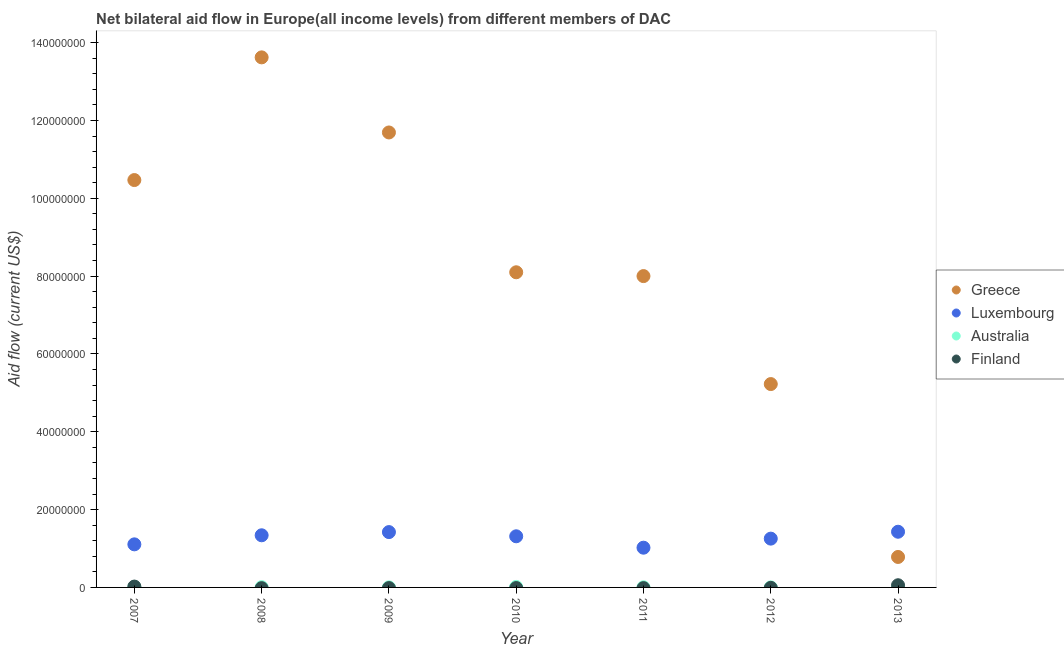How many different coloured dotlines are there?
Your answer should be compact. 4. What is the amount of aid given by australia in 2007?
Keep it short and to the point. 1.20e+05. Across all years, what is the maximum amount of aid given by luxembourg?
Give a very brief answer. 1.43e+07. Across all years, what is the minimum amount of aid given by greece?
Provide a short and direct response. 7.83e+06. What is the total amount of aid given by luxembourg in the graph?
Offer a terse response. 8.89e+07. What is the difference between the amount of aid given by greece in 2007 and that in 2010?
Give a very brief answer. 2.37e+07. What is the difference between the amount of aid given by greece in 2013 and the amount of aid given by australia in 2008?
Offer a terse response. 7.76e+06. What is the average amount of aid given by australia per year?
Your answer should be very brief. 5.86e+04. In the year 2009, what is the difference between the amount of aid given by luxembourg and amount of aid given by australia?
Offer a very short reply. 1.42e+07. What is the ratio of the amount of aid given by greece in 2008 to that in 2013?
Offer a terse response. 17.4. Is the amount of aid given by greece in 2009 less than that in 2011?
Make the answer very short. No. Is the difference between the amount of aid given by greece in 2008 and 2009 greater than the difference between the amount of aid given by australia in 2008 and 2009?
Provide a short and direct response. Yes. What is the difference between the highest and the second highest amount of aid given by luxembourg?
Ensure brevity in your answer.  9.00e+04. What is the difference between the highest and the lowest amount of aid given by finland?
Offer a very short reply. 5.60e+05. In how many years, is the amount of aid given by finland greater than the average amount of aid given by finland taken over all years?
Your response must be concise. 2. Is the sum of the amount of aid given by greece in 2012 and 2013 greater than the maximum amount of aid given by finland across all years?
Provide a short and direct response. Yes. Is it the case that in every year, the sum of the amount of aid given by luxembourg and amount of aid given by australia is greater than the sum of amount of aid given by greece and amount of aid given by finland?
Your answer should be compact. Yes. Is it the case that in every year, the sum of the amount of aid given by greece and amount of aid given by luxembourg is greater than the amount of aid given by australia?
Provide a short and direct response. Yes. Are the values on the major ticks of Y-axis written in scientific E-notation?
Make the answer very short. No. Does the graph contain any zero values?
Offer a very short reply. Yes. How are the legend labels stacked?
Your response must be concise. Vertical. What is the title of the graph?
Offer a terse response. Net bilateral aid flow in Europe(all income levels) from different members of DAC. Does "Methodology assessment" appear as one of the legend labels in the graph?
Give a very brief answer. No. What is the label or title of the Y-axis?
Make the answer very short. Aid flow (current US$). What is the Aid flow (current US$) of Greece in 2007?
Your answer should be very brief. 1.05e+08. What is the Aid flow (current US$) of Luxembourg in 2007?
Your answer should be compact. 1.11e+07. What is the Aid flow (current US$) in Finland in 2007?
Provide a short and direct response. 2.20e+05. What is the Aid flow (current US$) of Greece in 2008?
Provide a succinct answer. 1.36e+08. What is the Aid flow (current US$) of Luxembourg in 2008?
Make the answer very short. 1.34e+07. What is the Aid flow (current US$) of Finland in 2008?
Give a very brief answer. 0. What is the Aid flow (current US$) of Greece in 2009?
Keep it short and to the point. 1.17e+08. What is the Aid flow (current US$) in Luxembourg in 2009?
Provide a succinct answer. 1.42e+07. What is the Aid flow (current US$) of Australia in 2009?
Make the answer very short. 2.00e+04. What is the Aid flow (current US$) in Greece in 2010?
Your answer should be compact. 8.10e+07. What is the Aid flow (current US$) of Luxembourg in 2010?
Provide a short and direct response. 1.31e+07. What is the Aid flow (current US$) of Greece in 2011?
Your answer should be very brief. 8.00e+07. What is the Aid flow (current US$) in Luxembourg in 2011?
Offer a very short reply. 1.02e+07. What is the Aid flow (current US$) of Greece in 2012?
Make the answer very short. 5.23e+07. What is the Aid flow (current US$) in Luxembourg in 2012?
Provide a succinct answer. 1.25e+07. What is the Aid flow (current US$) in Australia in 2012?
Provide a succinct answer. 10000. What is the Aid flow (current US$) in Greece in 2013?
Your answer should be very brief. 7.83e+06. What is the Aid flow (current US$) in Luxembourg in 2013?
Your response must be concise. 1.43e+07. What is the Aid flow (current US$) in Finland in 2013?
Keep it short and to the point. 5.60e+05. Across all years, what is the maximum Aid flow (current US$) of Greece?
Make the answer very short. 1.36e+08. Across all years, what is the maximum Aid flow (current US$) in Luxembourg?
Provide a succinct answer. 1.43e+07. Across all years, what is the maximum Aid flow (current US$) of Australia?
Provide a short and direct response. 1.30e+05. Across all years, what is the maximum Aid flow (current US$) of Finland?
Your answer should be compact. 5.60e+05. Across all years, what is the minimum Aid flow (current US$) in Greece?
Make the answer very short. 7.83e+06. Across all years, what is the minimum Aid flow (current US$) of Luxembourg?
Offer a very short reply. 1.02e+07. Across all years, what is the minimum Aid flow (current US$) in Australia?
Offer a terse response. 10000. Across all years, what is the minimum Aid flow (current US$) in Finland?
Make the answer very short. 0. What is the total Aid flow (current US$) in Greece in the graph?
Offer a very short reply. 5.79e+08. What is the total Aid flow (current US$) of Luxembourg in the graph?
Offer a terse response. 8.89e+07. What is the total Aid flow (current US$) in Australia in the graph?
Give a very brief answer. 4.10e+05. What is the total Aid flow (current US$) in Finland in the graph?
Offer a terse response. 7.80e+05. What is the difference between the Aid flow (current US$) of Greece in 2007 and that in 2008?
Ensure brevity in your answer.  -3.15e+07. What is the difference between the Aid flow (current US$) in Luxembourg in 2007 and that in 2008?
Your answer should be compact. -2.33e+06. What is the difference between the Aid flow (current US$) in Australia in 2007 and that in 2008?
Offer a very short reply. 5.00e+04. What is the difference between the Aid flow (current US$) of Greece in 2007 and that in 2009?
Your response must be concise. -1.22e+07. What is the difference between the Aid flow (current US$) in Luxembourg in 2007 and that in 2009?
Ensure brevity in your answer.  -3.15e+06. What is the difference between the Aid flow (current US$) of Australia in 2007 and that in 2009?
Provide a short and direct response. 1.00e+05. What is the difference between the Aid flow (current US$) in Greece in 2007 and that in 2010?
Provide a succinct answer. 2.37e+07. What is the difference between the Aid flow (current US$) in Luxembourg in 2007 and that in 2010?
Your answer should be compact. -2.07e+06. What is the difference between the Aid flow (current US$) of Greece in 2007 and that in 2011?
Ensure brevity in your answer.  2.47e+07. What is the difference between the Aid flow (current US$) of Luxembourg in 2007 and that in 2011?
Ensure brevity in your answer.  8.60e+05. What is the difference between the Aid flow (current US$) of Greece in 2007 and that in 2012?
Your answer should be compact. 5.24e+07. What is the difference between the Aid flow (current US$) in Luxembourg in 2007 and that in 2012?
Keep it short and to the point. -1.47e+06. What is the difference between the Aid flow (current US$) of Greece in 2007 and that in 2013?
Keep it short and to the point. 9.69e+07. What is the difference between the Aid flow (current US$) of Luxembourg in 2007 and that in 2013?
Provide a short and direct response. -3.24e+06. What is the difference between the Aid flow (current US$) in Australia in 2007 and that in 2013?
Make the answer very short. 1.00e+05. What is the difference between the Aid flow (current US$) in Greece in 2008 and that in 2009?
Offer a very short reply. 1.93e+07. What is the difference between the Aid flow (current US$) in Luxembourg in 2008 and that in 2009?
Keep it short and to the point. -8.20e+05. What is the difference between the Aid flow (current US$) in Australia in 2008 and that in 2009?
Give a very brief answer. 5.00e+04. What is the difference between the Aid flow (current US$) in Greece in 2008 and that in 2010?
Offer a very short reply. 5.52e+07. What is the difference between the Aid flow (current US$) of Luxembourg in 2008 and that in 2010?
Offer a very short reply. 2.60e+05. What is the difference between the Aid flow (current US$) in Greece in 2008 and that in 2011?
Your answer should be compact. 5.62e+07. What is the difference between the Aid flow (current US$) in Luxembourg in 2008 and that in 2011?
Offer a very short reply. 3.19e+06. What is the difference between the Aid flow (current US$) in Australia in 2008 and that in 2011?
Provide a short and direct response. 3.00e+04. What is the difference between the Aid flow (current US$) of Greece in 2008 and that in 2012?
Keep it short and to the point. 8.40e+07. What is the difference between the Aid flow (current US$) of Luxembourg in 2008 and that in 2012?
Offer a very short reply. 8.60e+05. What is the difference between the Aid flow (current US$) of Australia in 2008 and that in 2012?
Your response must be concise. 6.00e+04. What is the difference between the Aid flow (current US$) in Greece in 2008 and that in 2013?
Make the answer very short. 1.28e+08. What is the difference between the Aid flow (current US$) in Luxembourg in 2008 and that in 2013?
Provide a short and direct response. -9.10e+05. What is the difference between the Aid flow (current US$) of Australia in 2008 and that in 2013?
Provide a short and direct response. 5.00e+04. What is the difference between the Aid flow (current US$) in Greece in 2009 and that in 2010?
Provide a short and direct response. 3.59e+07. What is the difference between the Aid flow (current US$) of Luxembourg in 2009 and that in 2010?
Ensure brevity in your answer.  1.08e+06. What is the difference between the Aid flow (current US$) of Australia in 2009 and that in 2010?
Offer a very short reply. -1.10e+05. What is the difference between the Aid flow (current US$) of Greece in 2009 and that in 2011?
Provide a succinct answer. 3.69e+07. What is the difference between the Aid flow (current US$) of Luxembourg in 2009 and that in 2011?
Keep it short and to the point. 4.01e+06. What is the difference between the Aid flow (current US$) in Greece in 2009 and that in 2012?
Give a very brief answer. 6.47e+07. What is the difference between the Aid flow (current US$) in Luxembourg in 2009 and that in 2012?
Offer a terse response. 1.68e+06. What is the difference between the Aid flow (current US$) of Australia in 2009 and that in 2012?
Make the answer very short. 10000. What is the difference between the Aid flow (current US$) in Greece in 2009 and that in 2013?
Keep it short and to the point. 1.09e+08. What is the difference between the Aid flow (current US$) of Luxembourg in 2009 and that in 2013?
Ensure brevity in your answer.  -9.00e+04. What is the difference between the Aid flow (current US$) of Greece in 2010 and that in 2011?
Provide a short and direct response. 9.80e+05. What is the difference between the Aid flow (current US$) in Luxembourg in 2010 and that in 2011?
Provide a short and direct response. 2.93e+06. What is the difference between the Aid flow (current US$) in Australia in 2010 and that in 2011?
Provide a short and direct response. 9.00e+04. What is the difference between the Aid flow (current US$) of Greece in 2010 and that in 2012?
Provide a short and direct response. 2.87e+07. What is the difference between the Aid flow (current US$) in Luxembourg in 2010 and that in 2012?
Provide a short and direct response. 6.00e+05. What is the difference between the Aid flow (current US$) in Greece in 2010 and that in 2013?
Offer a very short reply. 7.32e+07. What is the difference between the Aid flow (current US$) of Luxembourg in 2010 and that in 2013?
Make the answer very short. -1.17e+06. What is the difference between the Aid flow (current US$) of Greece in 2011 and that in 2012?
Give a very brief answer. 2.78e+07. What is the difference between the Aid flow (current US$) in Luxembourg in 2011 and that in 2012?
Provide a succinct answer. -2.33e+06. What is the difference between the Aid flow (current US$) in Greece in 2011 and that in 2013?
Offer a very short reply. 7.22e+07. What is the difference between the Aid flow (current US$) in Luxembourg in 2011 and that in 2013?
Provide a succinct answer. -4.10e+06. What is the difference between the Aid flow (current US$) of Australia in 2011 and that in 2013?
Your answer should be very brief. 2.00e+04. What is the difference between the Aid flow (current US$) of Greece in 2012 and that in 2013?
Keep it short and to the point. 4.44e+07. What is the difference between the Aid flow (current US$) of Luxembourg in 2012 and that in 2013?
Ensure brevity in your answer.  -1.77e+06. What is the difference between the Aid flow (current US$) of Greece in 2007 and the Aid flow (current US$) of Luxembourg in 2008?
Ensure brevity in your answer.  9.13e+07. What is the difference between the Aid flow (current US$) in Greece in 2007 and the Aid flow (current US$) in Australia in 2008?
Offer a very short reply. 1.05e+08. What is the difference between the Aid flow (current US$) in Luxembourg in 2007 and the Aid flow (current US$) in Australia in 2008?
Provide a succinct answer. 1.10e+07. What is the difference between the Aid flow (current US$) of Greece in 2007 and the Aid flow (current US$) of Luxembourg in 2009?
Your answer should be compact. 9.05e+07. What is the difference between the Aid flow (current US$) in Greece in 2007 and the Aid flow (current US$) in Australia in 2009?
Keep it short and to the point. 1.05e+08. What is the difference between the Aid flow (current US$) in Luxembourg in 2007 and the Aid flow (current US$) in Australia in 2009?
Offer a terse response. 1.10e+07. What is the difference between the Aid flow (current US$) of Greece in 2007 and the Aid flow (current US$) of Luxembourg in 2010?
Your answer should be very brief. 9.16e+07. What is the difference between the Aid flow (current US$) of Greece in 2007 and the Aid flow (current US$) of Australia in 2010?
Offer a very short reply. 1.05e+08. What is the difference between the Aid flow (current US$) in Luxembourg in 2007 and the Aid flow (current US$) in Australia in 2010?
Give a very brief answer. 1.09e+07. What is the difference between the Aid flow (current US$) in Greece in 2007 and the Aid flow (current US$) in Luxembourg in 2011?
Give a very brief answer. 9.45e+07. What is the difference between the Aid flow (current US$) of Greece in 2007 and the Aid flow (current US$) of Australia in 2011?
Keep it short and to the point. 1.05e+08. What is the difference between the Aid flow (current US$) of Luxembourg in 2007 and the Aid flow (current US$) of Australia in 2011?
Give a very brief answer. 1.10e+07. What is the difference between the Aid flow (current US$) in Greece in 2007 and the Aid flow (current US$) in Luxembourg in 2012?
Your answer should be very brief. 9.22e+07. What is the difference between the Aid flow (current US$) of Greece in 2007 and the Aid flow (current US$) of Australia in 2012?
Provide a short and direct response. 1.05e+08. What is the difference between the Aid flow (current US$) of Luxembourg in 2007 and the Aid flow (current US$) of Australia in 2012?
Make the answer very short. 1.11e+07. What is the difference between the Aid flow (current US$) of Greece in 2007 and the Aid flow (current US$) of Luxembourg in 2013?
Your answer should be compact. 9.04e+07. What is the difference between the Aid flow (current US$) of Greece in 2007 and the Aid flow (current US$) of Australia in 2013?
Your response must be concise. 1.05e+08. What is the difference between the Aid flow (current US$) in Greece in 2007 and the Aid flow (current US$) in Finland in 2013?
Give a very brief answer. 1.04e+08. What is the difference between the Aid flow (current US$) of Luxembourg in 2007 and the Aid flow (current US$) of Australia in 2013?
Offer a terse response. 1.10e+07. What is the difference between the Aid flow (current US$) of Luxembourg in 2007 and the Aid flow (current US$) of Finland in 2013?
Give a very brief answer. 1.05e+07. What is the difference between the Aid flow (current US$) in Australia in 2007 and the Aid flow (current US$) in Finland in 2013?
Your response must be concise. -4.40e+05. What is the difference between the Aid flow (current US$) of Greece in 2008 and the Aid flow (current US$) of Luxembourg in 2009?
Provide a succinct answer. 1.22e+08. What is the difference between the Aid flow (current US$) in Greece in 2008 and the Aid flow (current US$) in Australia in 2009?
Your answer should be compact. 1.36e+08. What is the difference between the Aid flow (current US$) in Luxembourg in 2008 and the Aid flow (current US$) in Australia in 2009?
Keep it short and to the point. 1.34e+07. What is the difference between the Aid flow (current US$) of Greece in 2008 and the Aid flow (current US$) of Luxembourg in 2010?
Keep it short and to the point. 1.23e+08. What is the difference between the Aid flow (current US$) of Greece in 2008 and the Aid flow (current US$) of Australia in 2010?
Provide a short and direct response. 1.36e+08. What is the difference between the Aid flow (current US$) of Luxembourg in 2008 and the Aid flow (current US$) of Australia in 2010?
Provide a succinct answer. 1.33e+07. What is the difference between the Aid flow (current US$) of Greece in 2008 and the Aid flow (current US$) of Luxembourg in 2011?
Keep it short and to the point. 1.26e+08. What is the difference between the Aid flow (current US$) in Greece in 2008 and the Aid flow (current US$) in Australia in 2011?
Offer a terse response. 1.36e+08. What is the difference between the Aid flow (current US$) of Luxembourg in 2008 and the Aid flow (current US$) of Australia in 2011?
Provide a succinct answer. 1.34e+07. What is the difference between the Aid flow (current US$) of Greece in 2008 and the Aid flow (current US$) of Luxembourg in 2012?
Keep it short and to the point. 1.24e+08. What is the difference between the Aid flow (current US$) in Greece in 2008 and the Aid flow (current US$) in Australia in 2012?
Keep it short and to the point. 1.36e+08. What is the difference between the Aid flow (current US$) in Luxembourg in 2008 and the Aid flow (current US$) in Australia in 2012?
Your response must be concise. 1.34e+07. What is the difference between the Aid flow (current US$) in Greece in 2008 and the Aid flow (current US$) in Luxembourg in 2013?
Your answer should be very brief. 1.22e+08. What is the difference between the Aid flow (current US$) in Greece in 2008 and the Aid flow (current US$) in Australia in 2013?
Your answer should be very brief. 1.36e+08. What is the difference between the Aid flow (current US$) of Greece in 2008 and the Aid flow (current US$) of Finland in 2013?
Provide a short and direct response. 1.36e+08. What is the difference between the Aid flow (current US$) of Luxembourg in 2008 and the Aid flow (current US$) of Australia in 2013?
Offer a very short reply. 1.34e+07. What is the difference between the Aid flow (current US$) of Luxembourg in 2008 and the Aid flow (current US$) of Finland in 2013?
Give a very brief answer. 1.28e+07. What is the difference between the Aid flow (current US$) in Australia in 2008 and the Aid flow (current US$) in Finland in 2013?
Keep it short and to the point. -4.90e+05. What is the difference between the Aid flow (current US$) in Greece in 2009 and the Aid flow (current US$) in Luxembourg in 2010?
Your answer should be very brief. 1.04e+08. What is the difference between the Aid flow (current US$) in Greece in 2009 and the Aid flow (current US$) in Australia in 2010?
Your answer should be compact. 1.17e+08. What is the difference between the Aid flow (current US$) in Luxembourg in 2009 and the Aid flow (current US$) in Australia in 2010?
Provide a succinct answer. 1.41e+07. What is the difference between the Aid flow (current US$) of Greece in 2009 and the Aid flow (current US$) of Luxembourg in 2011?
Keep it short and to the point. 1.07e+08. What is the difference between the Aid flow (current US$) in Greece in 2009 and the Aid flow (current US$) in Australia in 2011?
Offer a very short reply. 1.17e+08. What is the difference between the Aid flow (current US$) of Luxembourg in 2009 and the Aid flow (current US$) of Australia in 2011?
Give a very brief answer. 1.42e+07. What is the difference between the Aid flow (current US$) in Greece in 2009 and the Aid flow (current US$) in Luxembourg in 2012?
Offer a very short reply. 1.04e+08. What is the difference between the Aid flow (current US$) of Greece in 2009 and the Aid flow (current US$) of Australia in 2012?
Keep it short and to the point. 1.17e+08. What is the difference between the Aid flow (current US$) in Luxembourg in 2009 and the Aid flow (current US$) in Australia in 2012?
Ensure brevity in your answer.  1.42e+07. What is the difference between the Aid flow (current US$) in Greece in 2009 and the Aid flow (current US$) in Luxembourg in 2013?
Ensure brevity in your answer.  1.03e+08. What is the difference between the Aid flow (current US$) of Greece in 2009 and the Aid flow (current US$) of Australia in 2013?
Your answer should be very brief. 1.17e+08. What is the difference between the Aid flow (current US$) in Greece in 2009 and the Aid flow (current US$) in Finland in 2013?
Ensure brevity in your answer.  1.16e+08. What is the difference between the Aid flow (current US$) in Luxembourg in 2009 and the Aid flow (current US$) in Australia in 2013?
Give a very brief answer. 1.42e+07. What is the difference between the Aid flow (current US$) of Luxembourg in 2009 and the Aid flow (current US$) of Finland in 2013?
Offer a very short reply. 1.37e+07. What is the difference between the Aid flow (current US$) in Australia in 2009 and the Aid flow (current US$) in Finland in 2013?
Keep it short and to the point. -5.40e+05. What is the difference between the Aid flow (current US$) in Greece in 2010 and the Aid flow (current US$) in Luxembourg in 2011?
Your answer should be very brief. 7.08e+07. What is the difference between the Aid flow (current US$) in Greece in 2010 and the Aid flow (current US$) in Australia in 2011?
Provide a short and direct response. 8.10e+07. What is the difference between the Aid flow (current US$) in Luxembourg in 2010 and the Aid flow (current US$) in Australia in 2011?
Keep it short and to the point. 1.31e+07. What is the difference between the Aid flow (current US$) in Greece in 2010 and the Aid flow (current US$) in Luxembourg in 2012?
Offer a terse response. 6.84e+07. What is the difference between the Aid flow (current US$) of Greece in 2010 and the Aid flow (current US$) of Australia in 2012?
Ensure brevity in your answer.  8.10e+07. What is the difference between the Aid flow (current US$) of Luxembourg in 2010 and the Aid flow (current US$) of Australia in 2012?
Provide a short and direct response. 1.31e+07. What is the difference between the Aid flow (current US$) in Greece in 2010 and the Aid flow (current US$) in Luxembourg in 2013?
Your answer should be compact. 6.67e+07. What is the difference between the Aid flow (current US$) of Greece in 2010 and the Aid flow (current US$) of Australia in 2013?
Your answer should be very brief. 8.10e+07. What is the difference between the Aid flow (current US$) in Greece in 2010 and the Aid flow (current US$) in Finland in 2013?
Offer a terse response. 8.04e+07. What is the difference between the Aid flow (current US$) of Luxembourg in 2010 and the Aid flow (current US$) of Australia in 2013?
Your answer should be very brief. 1.31e+07. What is the difference between the Aid flow (current US$) in Luxembourg in 2010 and the Aid flow (current US$) in Finland in 2013?
Your response must be concise. 1.26e+07. What is the difference between the Aid flow (current US$) of Australia in 2010 and the Aid flow (current US$) of Finland in 2013?
Provide a succinct answer. -4.30e+05. What is the difference between the Aid flow (current US$) of Greece in 2011 and the Aid flow (current US$) of Luxembourg in 2012?
Give a very brief answer. 6.75e+07. What is the difference between the Aid flow (current US$) in Greece in 2011 and the Aid flow (current US$) in Australia in 2012?
Give a very brief answer. 8.00e+07. What is the difference between the Aid flow (current US$) of Luxembourg in 2011 and the Aid flow (current US$) of Australia in 2012?
Make the answer very short. 1.02e+07. What is the difference between the Aid flow (current US$) of Greece in 2011 and the Aid flow (current US$) of Luxembourg in 2013?
Offer a terse response. 6.57e+07. What is the difference between the Aid flow (current US$) of Greece in 2011 and the Aid flow (current US$) of Australia in 2013?
Your answer should be compact. 8.00e+07. What is the difference between the Aid flow (current US$) in Greece in 2011 and the Aid flow (current US$) in Finland in 2013?
Your response must be concise. 7.94e+07. What is the difference between the Aid flow (current US$) in Luxembourg in 2011 and the Aid flow (current US$) in Australia in 2013?
Keep it short and to the point. 1.02e+07. What is the difference between the Aid flow (current US$) in Luxembourg in 2011 and the Aid flow (current US$) in Finland in 2013?
Give a very brief answer. 9.65e+06. What is the difference between the Aid flow (current US$) of Australia in 2011 and the Aid flow (current US$) of Finland in 2013?
Give a very brief answer. -5.20e+05. What is the difference between the Aid flow (current US$) of Greece in 2012 and the Aid flow (current US$) of Luxembourg in 2013?
Provide a succinct answer. 3.80e+07. What is the difference between the Aid flow (current US$) in Greece in 2012 and the Aid flow (current US$) in Australia in 2013?
Ensure brevity in your answer.  5.22e+07. What is the difference between the Aid flow (current US$) in Greece in 2012 and the Aid flow (current US$) in Finland in 2013?
Provide a short and direct response. 5.17e+07. What is the difference between the Aid flow (current US$) of Luxembourg in 2012 and the Aid flow (current US$) of Australia in 2013?
Give a very brief answer. 1.25e+07. What is the difference between the Aid flow (current US$) in Luxembourg in 2012 and the Aid flow (current US$) in Finland in 2013?
Your response must be concise. 1.20e+07. What is the difference between the Aid flow (current US$) of Australia in 2012 and the Aid flow (current US$) of Finland in 2013?
Your answer should be compact. -5.50e+05. What is the average Aid flow (current US$) in Greece per year?
Ensure brevity in your answer.  8.27e+07. What is the average Aid flow (current US$) in Luxembourg per year?
Make the answer very short. 1.27e+07. What is the average Aid flow (current US$) in Australia per year?
Your response must be concise. 5.86e+04. What is the average Aid flow (current US$) in Finland per year?
Give a very brief answer. 1.11e+05. In the year 2007, what is the difference between the Aid flow (current US$) in Greece and Aid flow (current US$) in Luxembourg?
Give a very brief answer. 9.36e+07. In the year 2007, what is the difference between the Aid flow (current US$) of Greece and Aid flow (current US$) of Australia?
Keep it short and to the point. 1.05e+08. In the year 2007, what is the difference between the Aid flow (current US$) in Greece and Aid flow (current US$) in Finland?
Make the answer very short. 1.04e+08. In the year 2007, what is the difference between the Aid flow (current US$) of Luxembourg and Aid flow (current US$) of Australia?
Your response must be concise. 1.10e+07. In the year 2007, what is the difference between the Aid flow (current US$) in Luxembourg and Aid flow (current US$) in Finland?
Keep it short and to the point. 1.08e+07. In the year 2008, what is the difference between the Aid flow (current US$) in Greece and Aid flow (current US$) in Luxembourg?
Provide a short and direct response. 1.23e+08. In the year 2008, what is the difference between the Aid flow (current US$) of Greece and Aid flow (current US$) of Australia?
Make the answer very short. 1.36e+08. In the year 2008, what is the difference between the Aid flow (current US$) of Luxembourg and Aid flow (current US$) of Australia?
Keep it short and to the point. 1.33e+07. In the year 2009, what is the difference between the Aid flow (current US$) of Greece and Aid flow (current US$) of Luxembourg?
Keep it short and to the point. 1.03e+08. In the year 2009, what is the difference between the Aid flow (current US$) of Greece and Aid flow (current US$) of Australia?
Keep it short and to the point. 1.17e+08. In the year 2009, what is the difference between the Aid flow (current US$) of Luxembourg and Aid flow (current US$) of Australia?
Provide a short and direct response. 1.42e+07. In the year 2010, what is the difference between the Aid flow (current US$) of Greece and Aid flow (current US$) of Luxembourg?
Provide a short and direct response. 6.78e+07. In the year 2010, what is the difference between the Aid flow (current US$) in Greece and Aid flow (current US$) in Australia?
Give a very brief answer. 8.09e+07. In the year 2010, what is the difference between the Aid flow (current US$) of Luxembourg and Aid flow (current US$) of Australia?
Ensure brevity in your answer.  1.30e+07. In the year 2011, what is the difference between the Aid flow (current US$) in Greece and Aid flow (current US$) in Luxembourg?
Give a very brief answer. 6.98e+07. In the year 2011, what is the difference between the Aid flow (current US$) of Greece and Aid flow (current US$) of Australia?
Give a very brief answer. 8.00e+07. In the year 2011, what is the difference between the Aid flow (current US$) of Luxembourg and Aid flow (current US$) of Australia?
Give a very brief answer. 1.02e+07. In the year 2012, what is the difference between the Aid flow (current US$) of Greece and Aid flow (current US$) of Luxembourg?
Provide a short and direct response. 3.97e+07. In the year 2012, what is the difference between the Aid flow (current US$) in Greece and Aid flow (current US$) in Australia?
Offer a terse response. 5.22e+07. In the year 2012, what is the difference between the Aid flow (current US$) of Luxembourg and Aid flow (current US$) of Australia?
Ensure brevity in your answer.  1.25e+07. In the year 2013, what is the difference between the Aid flow (current US$) in Greece and Aid flow (current US$) in Luxembourg?
Your answer should be very brief. -6.48e+06. In the year 2013, what is the difference between the Aid flow (current US$) in Greece and Aid flow (current US$) in Australia?
Offer a terse response. 7.81e+06. In the year 2013, what is the difference between the Aid flow (current US$) in Greece and Aid flow (current US$) in Finland?
Offer a terse response. 7.27e+06. In the year 2013, what is the difference between the Aid flow (current US$) of Luxembourg and Aid flow (current US$) of Australia?
Offer a terse response. 1.43e+07. In the year 2013, what is the difference between the Aid flow (current US$) in Luxembourg and Aid flow (current US$) in Finland?
Offer a very short reply. 1.38e+07. In the year 2013, what is the difference between the Aid flow (current US$) in Australia and Aid flow (current US$) in Finland?
Provide a succinct answer. -5.40e+05. What is the ratio of the Aid flow (current US$) of Greece in 2007 to that in 2008?
Your answer should be very brief. 0.77. What is the ratio of the Aid flow (current US$) in Luxembourg in 2007 to that in 2008?
Make the answer very short. 0.83. What is the ratio of the Aid flow (current US$) in Australia in 2007 to that in 2008?
Provide a short and direct response. 1.71. What is the ratio of the Aid flow (current US$) in Greece in 2007 to that in 2009?
Ensure brevity in your answer.  0.9. What is the ratio of the Aid flow (current US$) in Luxembourg in 2007 to that in 2009?
Your answer should be very brief. 0.78. What is the ratio of the Aid flow (current US$) in Australia in 2007 to that in 2009?
Provide a succinct answer. 6. What is the ratio of the Aid flow (current US$) of Greece in 2007 to that in 2010?
Your response must be concise. 1.29. What is the ratio of the Aid flow (current US$) in Luxembourg in 2007 to that in 2010?
Offer a very short reply. 0.84. What is the ratio of the Aid flow (current US$) of Australia in 2007 to that in 2010?
Your answer should be very brief. 0.92. What is the ratio of the Aid flow (current US$) of Greece in 2007 to that in 2011?
Keep it short and to the point. 1.31. What is the ratio of the Aid flow (current US$) of Luxembourg in 2007 to that in 2011?
Offer a terse response. 1.08. What is the ratio of the Aid flow (current US$) of Greece in 2007 to that in 2012?
Offer a very short reply. 2. What is the ratio of the Aid flow (current US$) in Luxembourg in 2007 to that in 2012?
Make the answer very short. 0.88. What is the ratio of the Aid flow (current US$) of Australia in 2007 to that in 2012?
Your answer should be compact. 12. What is the ratio of the Aid flow (current US$) of Greece in 2007 to that in 2013?
Your answer should be compact. 13.37. What is the ratio of the Aid flow (current US$) of Luxembourg in 2007 to that in 2013?
Ensure brevity in your answer.  0.77. What is the ratio of the Aid flow (current US$) of Finland in 2007 to that in 2013?
Your answer should be compact. 0.39. What is the ratio of the Aid flow (current US$) in Greece in 2008 to that in 2009?
Ensure brevity in your answer.  1.17. What is the ratio of the Aid flow (current US$) in Luxembourg in 2008 to that in 2009?
Offer a very short reply. 0.94. What is the ratio of the Aid flow (current US$) in Australia in 2008 to that in 2009?
Offer a very short reply. 3.5. What is the ratio of the Aid flow (current US$) in Greece in 2008 to that in 2010?
Your answer should be very brief. 1.68. What is the ratio of the Aid flow (current US$) of Luxembourg in 2008 to that in 2010?
Your response must be concise. 1.02. What is the ratio of the Aid flow (current US$) in Australia in 2008 to that in 2010?
Offer a very short reply. 0.54. What is the ratio of the Aid flow (current US$) in Greece in 2008 to that in 2011?
Offer a very short reply. 1.7. What is the ratio of the Aid flow (current US$) in Luxembourg in 2008 to that in 2011?
Provide a short and direct response. 1.31. What is the ratio of the Aid flow (current US$) in Australia in 2008 to that in 2011?
Your answer should be very brief. 1.75. What is the ratio of the Aid flow (current US$) in Greece in 2008 to that in 2012?
Offer a terse response. 2.61. What is the ratio of the Aid flow (current US$) of Luxembourg in 2008 to that in 2012?
Offer a terse response. 1.07. What is the ratio of the Aid flow (current US$) in Australia in 2008 to that in 2012?
Give a very brief answer. 7. What is the ratio of the Aid flow (current US$) in Greece in 2008 to that in 2013?
Your response must be concise. 17.4. What is the ratio of the Aid flow (current US$) of Luxembourg in 2008 to that in 2013?
Your answer should be very brief. 0.94. What is the ratio of the Aid flow (current US$) in Greece in 2009 to that in 2010?
Offer a terse response. 1.44. What is the ratio of the Aid flow (current US$) of Luxembourg in 2009 to that in 2010?
Offer a very short reply. 1.08. What is the ratio of the Aid flow (current US$) in Australia in 2009 to that in 2010?
Keep it short and to the point. 0.15. What is the ratio of the Aid flow (current US$) in Greece in 2009 to that in 2011?
Offer a very short reply. 1.46. What is the ratio of the Aid flow (current US$) of Luxembourg in 2009 to that in 2011?
Your response must be concise. 1.39. What is the ratio of the Aid flow (current US$) of Greece in 2009 to that in 2012?
Make the answer very short. 2.24. What is the ratio of the Aid flow (current US$) of Luxembourg in 2009 to that in 2012?
Your answer should be compact. 1.13. What is the ratio of the Aid flow (current US$) of Greece in 2009 to that in 2013?
Your answer should be very brief. 14.93. What is the ratio of the Aid flow (current US$) of Luxembourg in 2009 to that in 2013?
Keep it short and to the point. 0.99. What is the ratio of the Aid flow (current US$) of Australia in 2009 to that in 2013?
Keep it short and to the point. 1. What is the ratio of the Aid flow (current US$) of Greece in 2010 to that in 2011?
Give a very brief answer. 1.01. What is the ratio of the Aid flow (current US$) of Luxembourg in 2010 to that in 2011?
Your answer should be very brief. 1.29. What is the ratio of the Aid flow (current US$) of Greece in 2010 to that in 2012?
Keep it short and to the point. 1.55. What is the ratio of the Aid flow (current US$) of Luxembourg in 2010 to that in 2012?
Your answer should be very brief. 1.05. What is the ratio of the Aid flow (current US$) of Greece in 2010 to that in 2013?
Make the answer very short. 10.34. What is the ratio of the Aid flow (current US$) of Luxembourg in 2010 to that in 2013?
Give a very brief answer. 0.92. What is the ratio of the Aid flow (current US$) in Australia in 2010 to that in 2013?
Provide a succinct answer. 6.5. What is the ratio of the Aid flow (current US$) of Greece in 2011 to that in 2012?
Provide a succinct answer. 1.53. What is the ratio of the Aid flow (current US$) of Luxembourg in 2011 to that in 2012?
Provide a succinct answer. 0.81. What is the ratio of the Aid flow (current US$) of Australia in 2011 to that in 2012?
Provide a short and direct response. 4. What is the ratio of the Aid flow (current US$) of Greece in 2011 to that in 2013?
Offer a terse response. 10.22. What is the ratio of the Aid flow (current US$) in Luxembourg in 2011 to that in 2013?
Offer a terse response. 0.71. What is the ratio of the Aid flow (current US$) of Greece in 2012 to that in 2013?
Offer a terse response. 6.67. What is the ratio of the Aid flow (current US$) in Luxembourg in 2012 to that in 2013?
Provide a short and direct response. 0.88. What is the ratio of the Aid flow (current US$) in Australia in 2012 to that in 2013?
Give a very brief answer. 0.5. What is the difference between the highest and the second highest Aid flow (current US$) of Greece?
Provide a short and direct response. 1.93e+07. What is the difference between the highest and the lowest Aid flow (current US$) of Greece?
Provide a short and direct response. 1.28e+08. What is the difference between the highest and the lowest Aid flow (current US$) of Luxembourg?
Your response must be concise. 4.10e+06. What is the difference between the highest and the lowest Aid flow (current US$) of Australia?
Provide a short and direct response. 1.20e+05. What is the difference between the highest and the lowest Aid flow (current US$) in Finland?
Provide a short and direct response. 5.60e+05. 